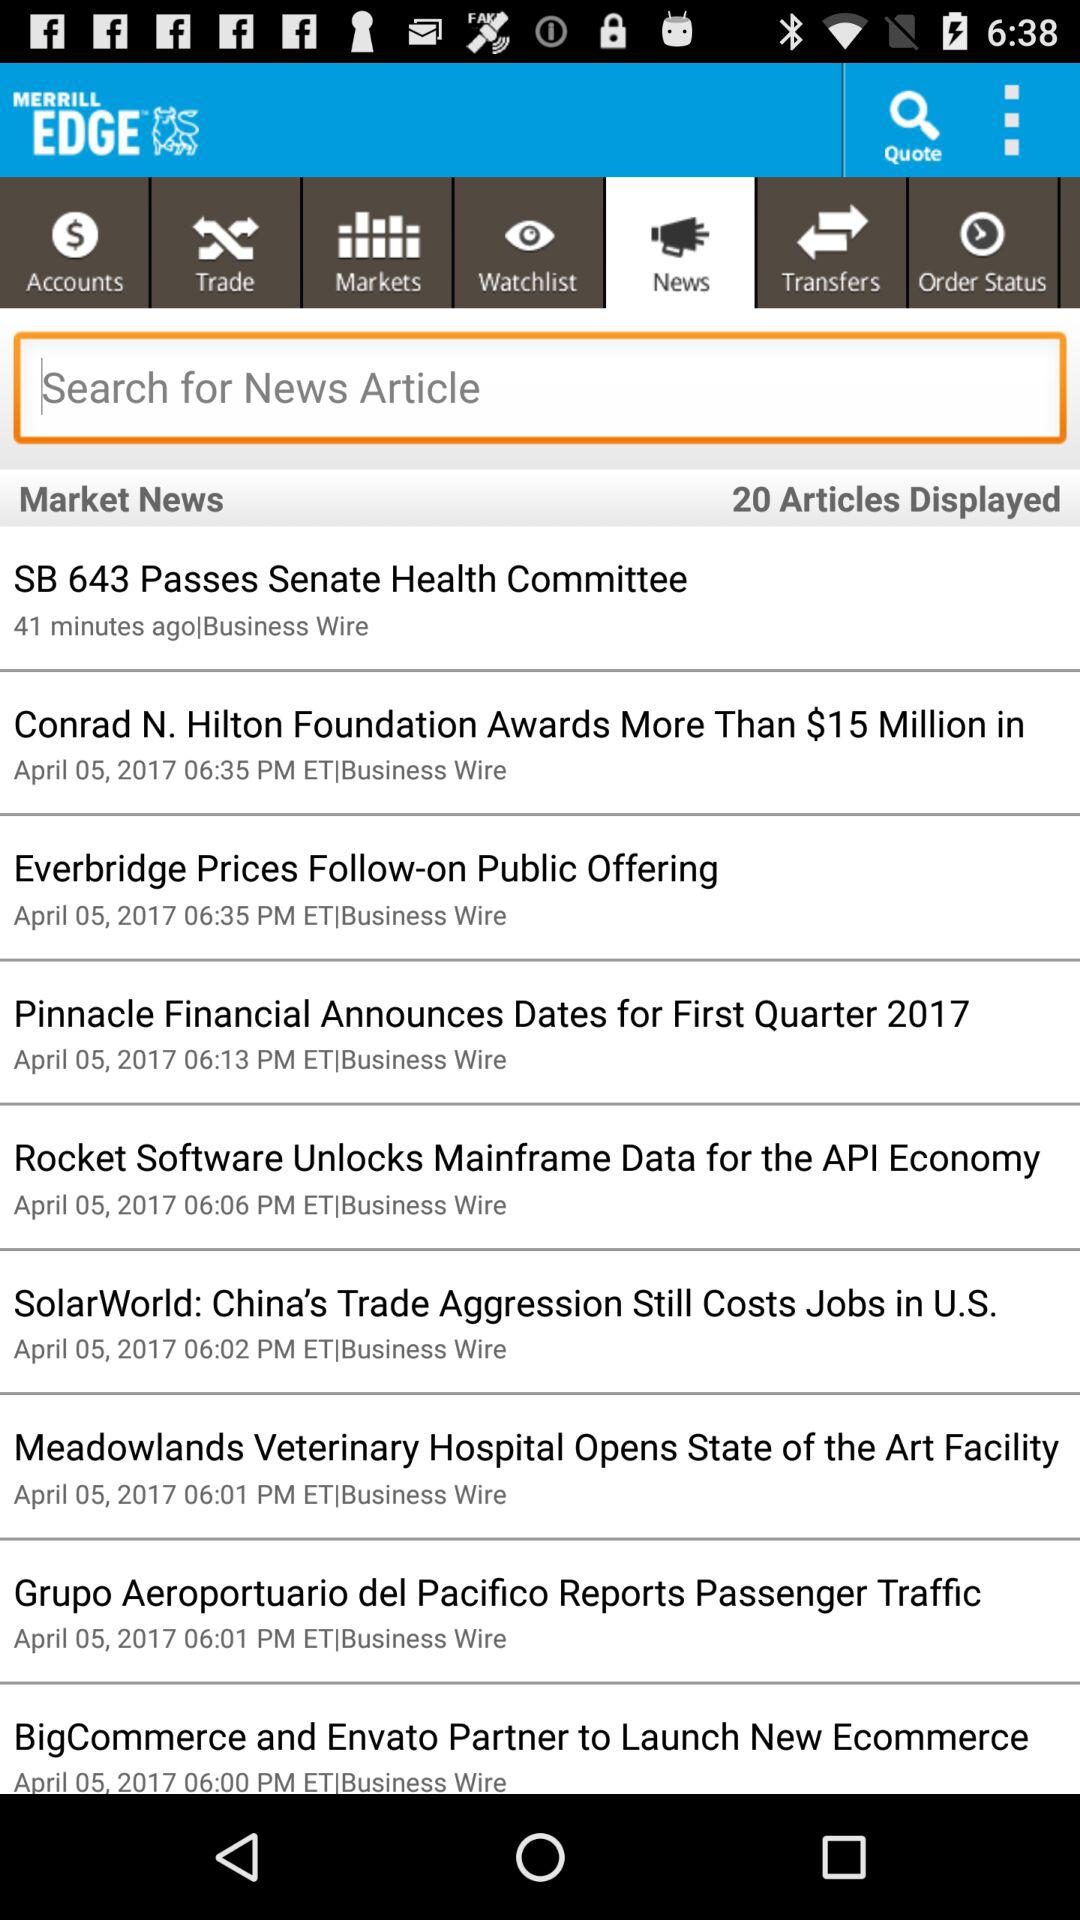How many articles are displayed? The displayed articles are 20. 